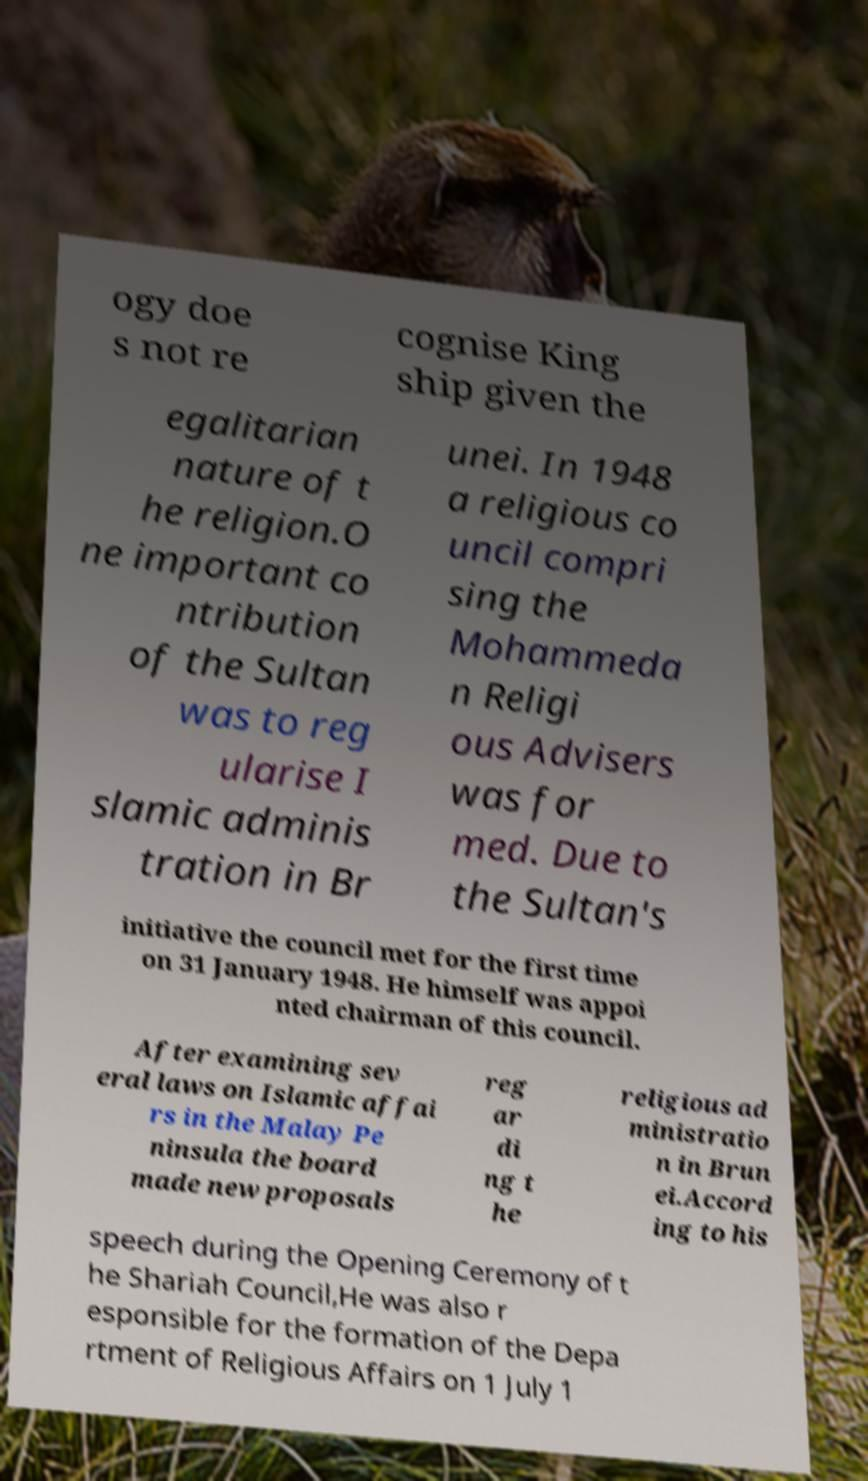For documentation purposes, I need the text within this image transcribed. Could you provide that? ogy doe s not re cognise King ship given the egalitarian nature of t he religion.O ne important co ntribution of the Sultan was to reg ularise I slamic adminis tration in Br unei. In 1948 a religious co uncil compri sing the Mohammeda n Religi ous Advisers was for med. Due to the Sultan's initiative the council met for the first time on 31 January 1948. He himself was appoi nted chairman of this council. After examining sev eral laws on Islamic affai rs in the Malay Pe ninsula the board made new proposals reg ar di ng t he religious ad ministratio n in Brun ei.Accord ing to his speech during the Opening Ceremony of t he Shariah Council,He was also r esponsible for the formation of the Depa rtment of Religious Affairs on 1 July 1 